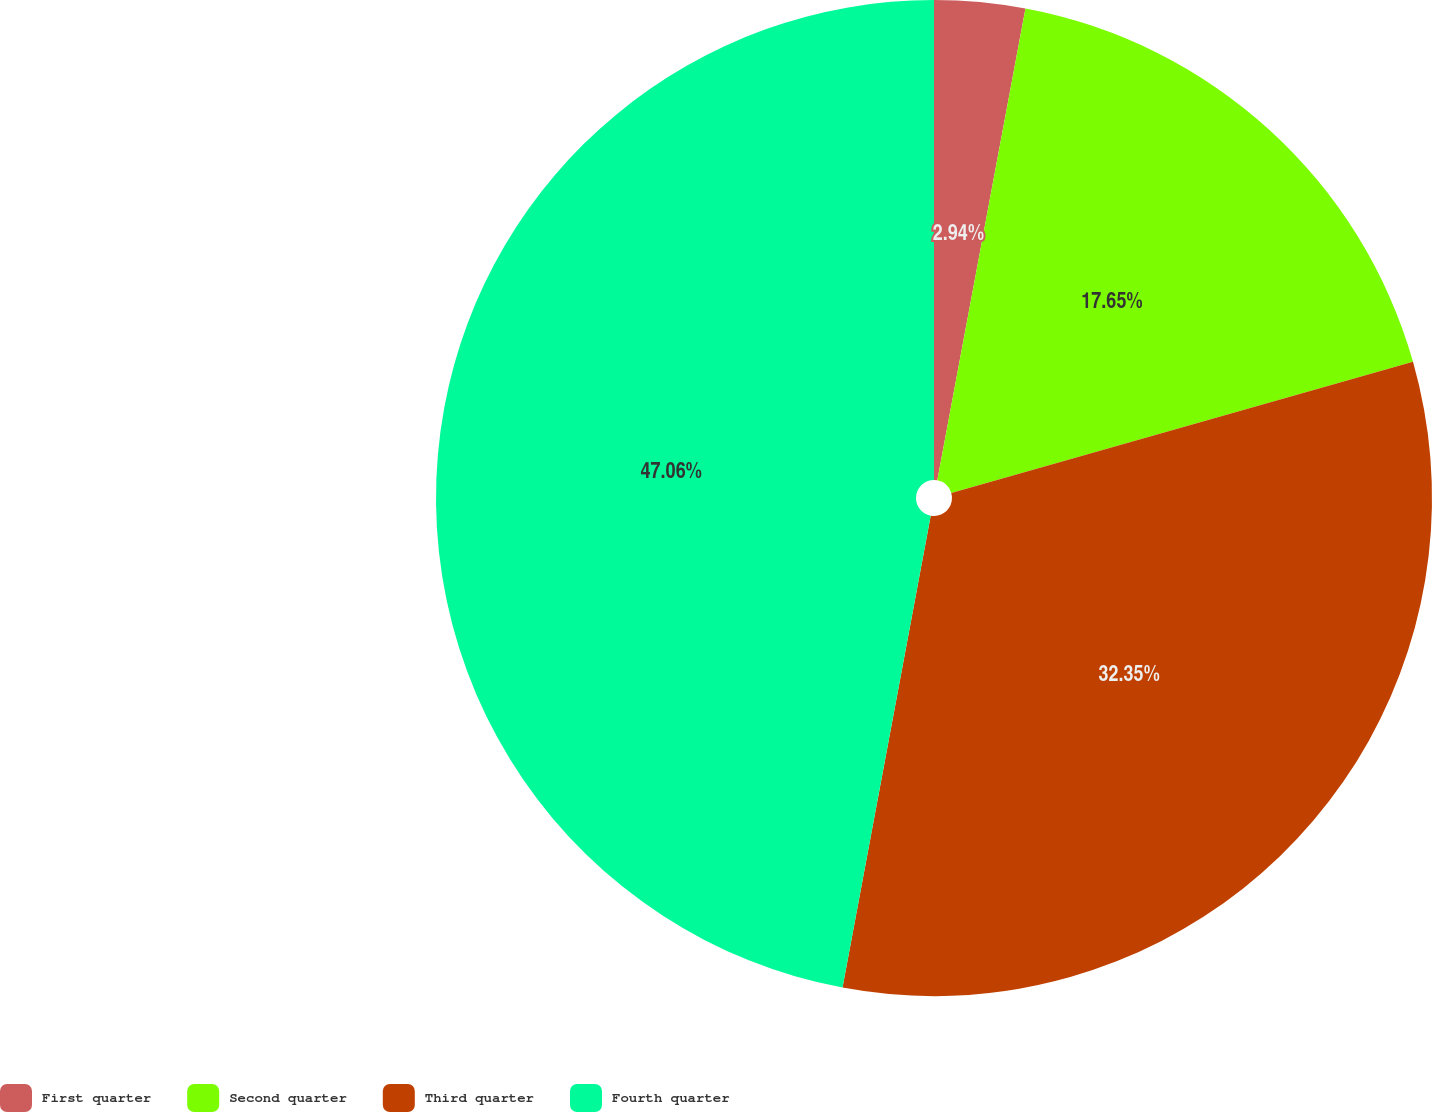Convert chart. <chart><loc_0><loc_0><loc_500><loc_500><pie_chart><fcel>First quarter<fcel>Second quarter<fcel>Third quarter<fcel>Fourth quarter<nl><fcel>2.94%<fcel>17.65%<fcel>32.35%<fcel>47.06%<nl></chart> 